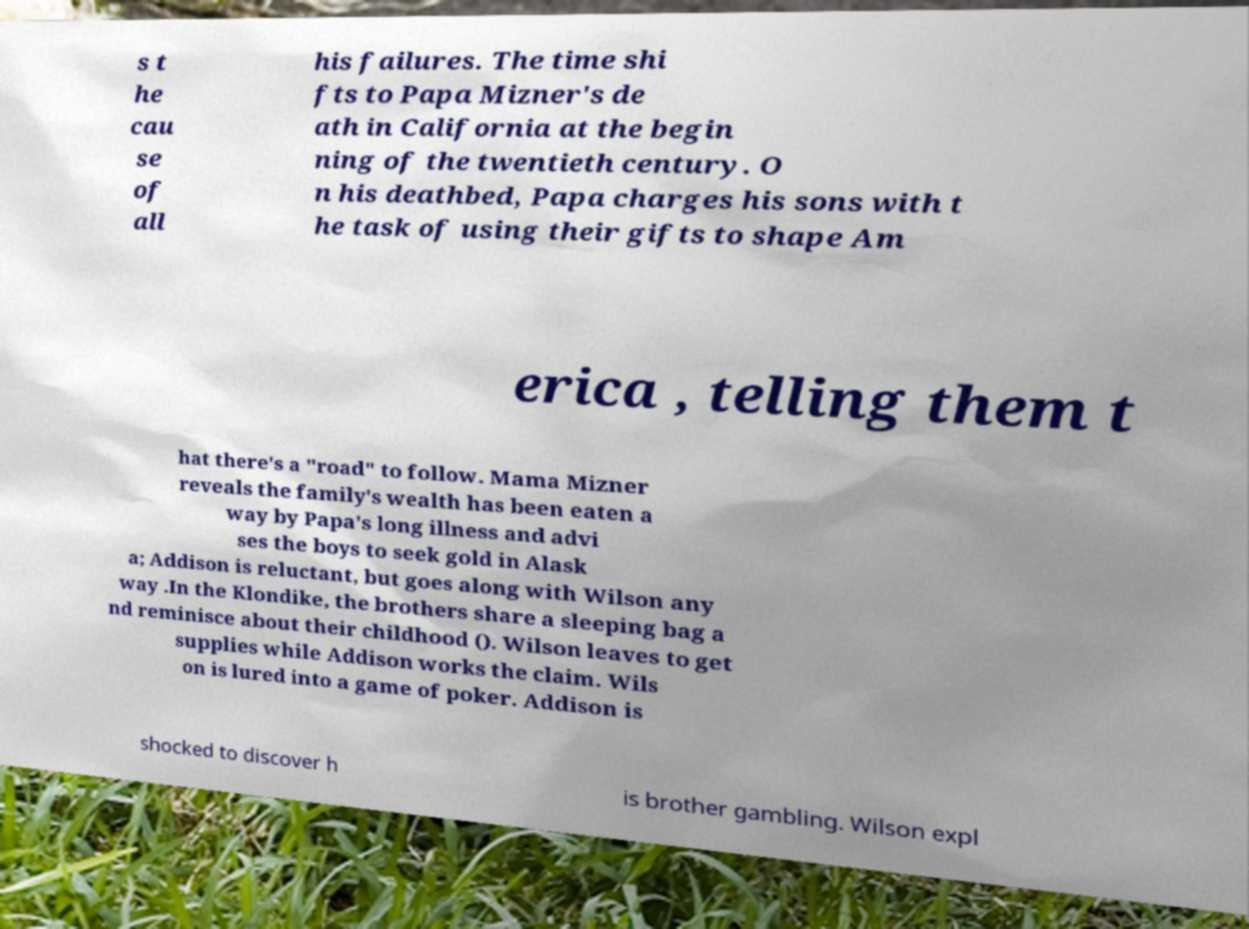I need the written content from this picture converted into text. Can you do that? s t he cau se of all his failures. The time shi fts to Papa Mizner's de ath in California at the begin ning of the twentieth century. O n his deathbed, Papa charges his sons with t he task of using their gifts to shape Am erica , telling them t hat there's a "road" to follow. Mama Mizner reveals the family's wealth has been eaten a way by Papa's long illness and advi ses the boys to seek gold in Alask a; Addison is reluctant, but goes along with Wilson any way .In the Klondike, the brothers share a sleeping bag a nd reminisce about their childhood (). Wilson leaves to get supplies while Addison works the claim. Wils on is lured into a game of poker. Addison is shocked to discover h is brother gambling. Wilson expl 